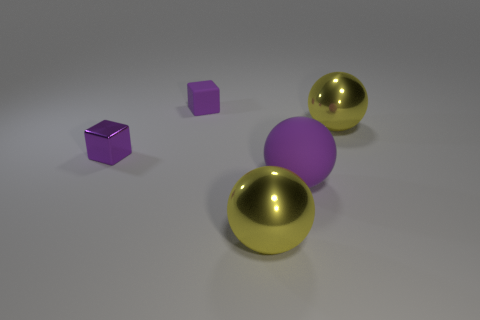Can you describe the setting or the environment in which these objects are placed? The objects are situated in a minimalistic and neutral space. It features a smooth, flat surface with a slight gradient, which may indicate a studio-like environment commonly used in 3D rendering or product photography. The absence of additional context or items puts the full focus on the geometry and materials of the shapes presented. What can be inferred about the size of the objects based on the image? Without a familiar object for scale, it's difficult to determine the exact size of the objects. However, based on the relative sizes and the perspective from which the image is taken, one might infer that the spheres have a considerable volume compared to the small cube, which seems to be of a size that could be easily held in one's hand. 